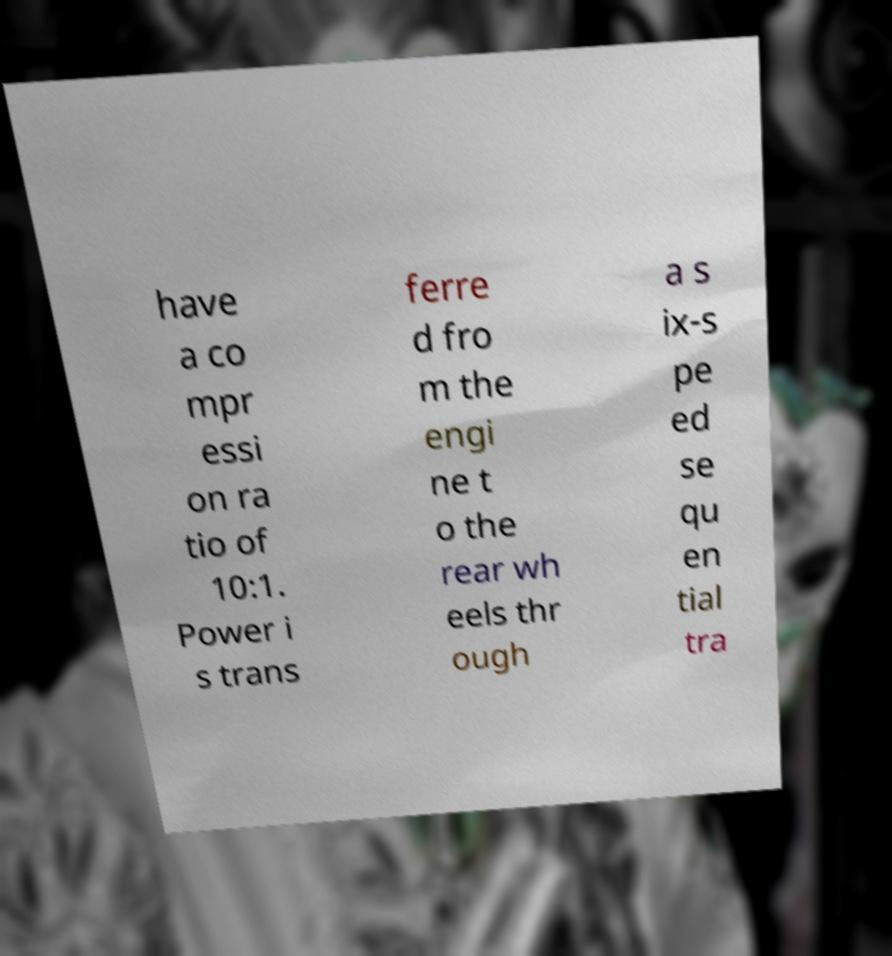There's text embedded in this image that I need extracted. Can you transcribe it verbatim? have a co mpr essi on ra tio of 10:1. Power i s trans ferre d fro m the engi ne t o the rear wh eels thr ough a s ix-s pe ed se qu en tial tra 